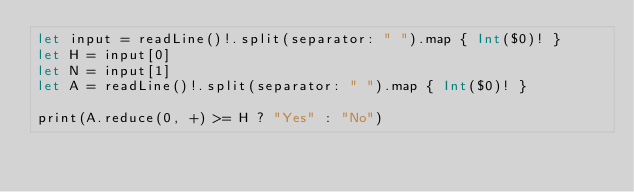<code> <loc_0><loc_0><loc_500><loc_500><_Swift_>let input = readLine()!.split(separator: " ").map { Int($0)! }
let H = input[0]
let N = input[1]
let A = readLine()!.split(separator: " ").map { Int($0)! }

print(A.reduce(0, +) >= H ? "Yes" : "No")</code> 